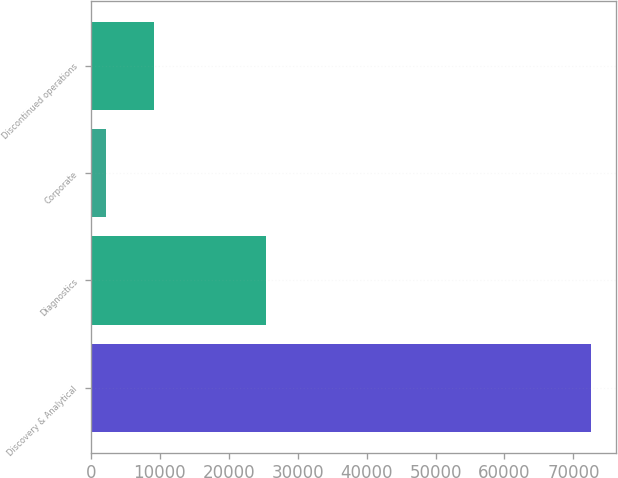<chart> <loc_0><loc_0><loc_500><loc_500><bar_chart><fcel>Discovery & Analytical<fcel>Diagnostics<fcel>Corporate<fcel>Discontinued operations<nl><fcel>72484<fcel>25339<fcel>2149<fcel>9182.5<nl></chart> 